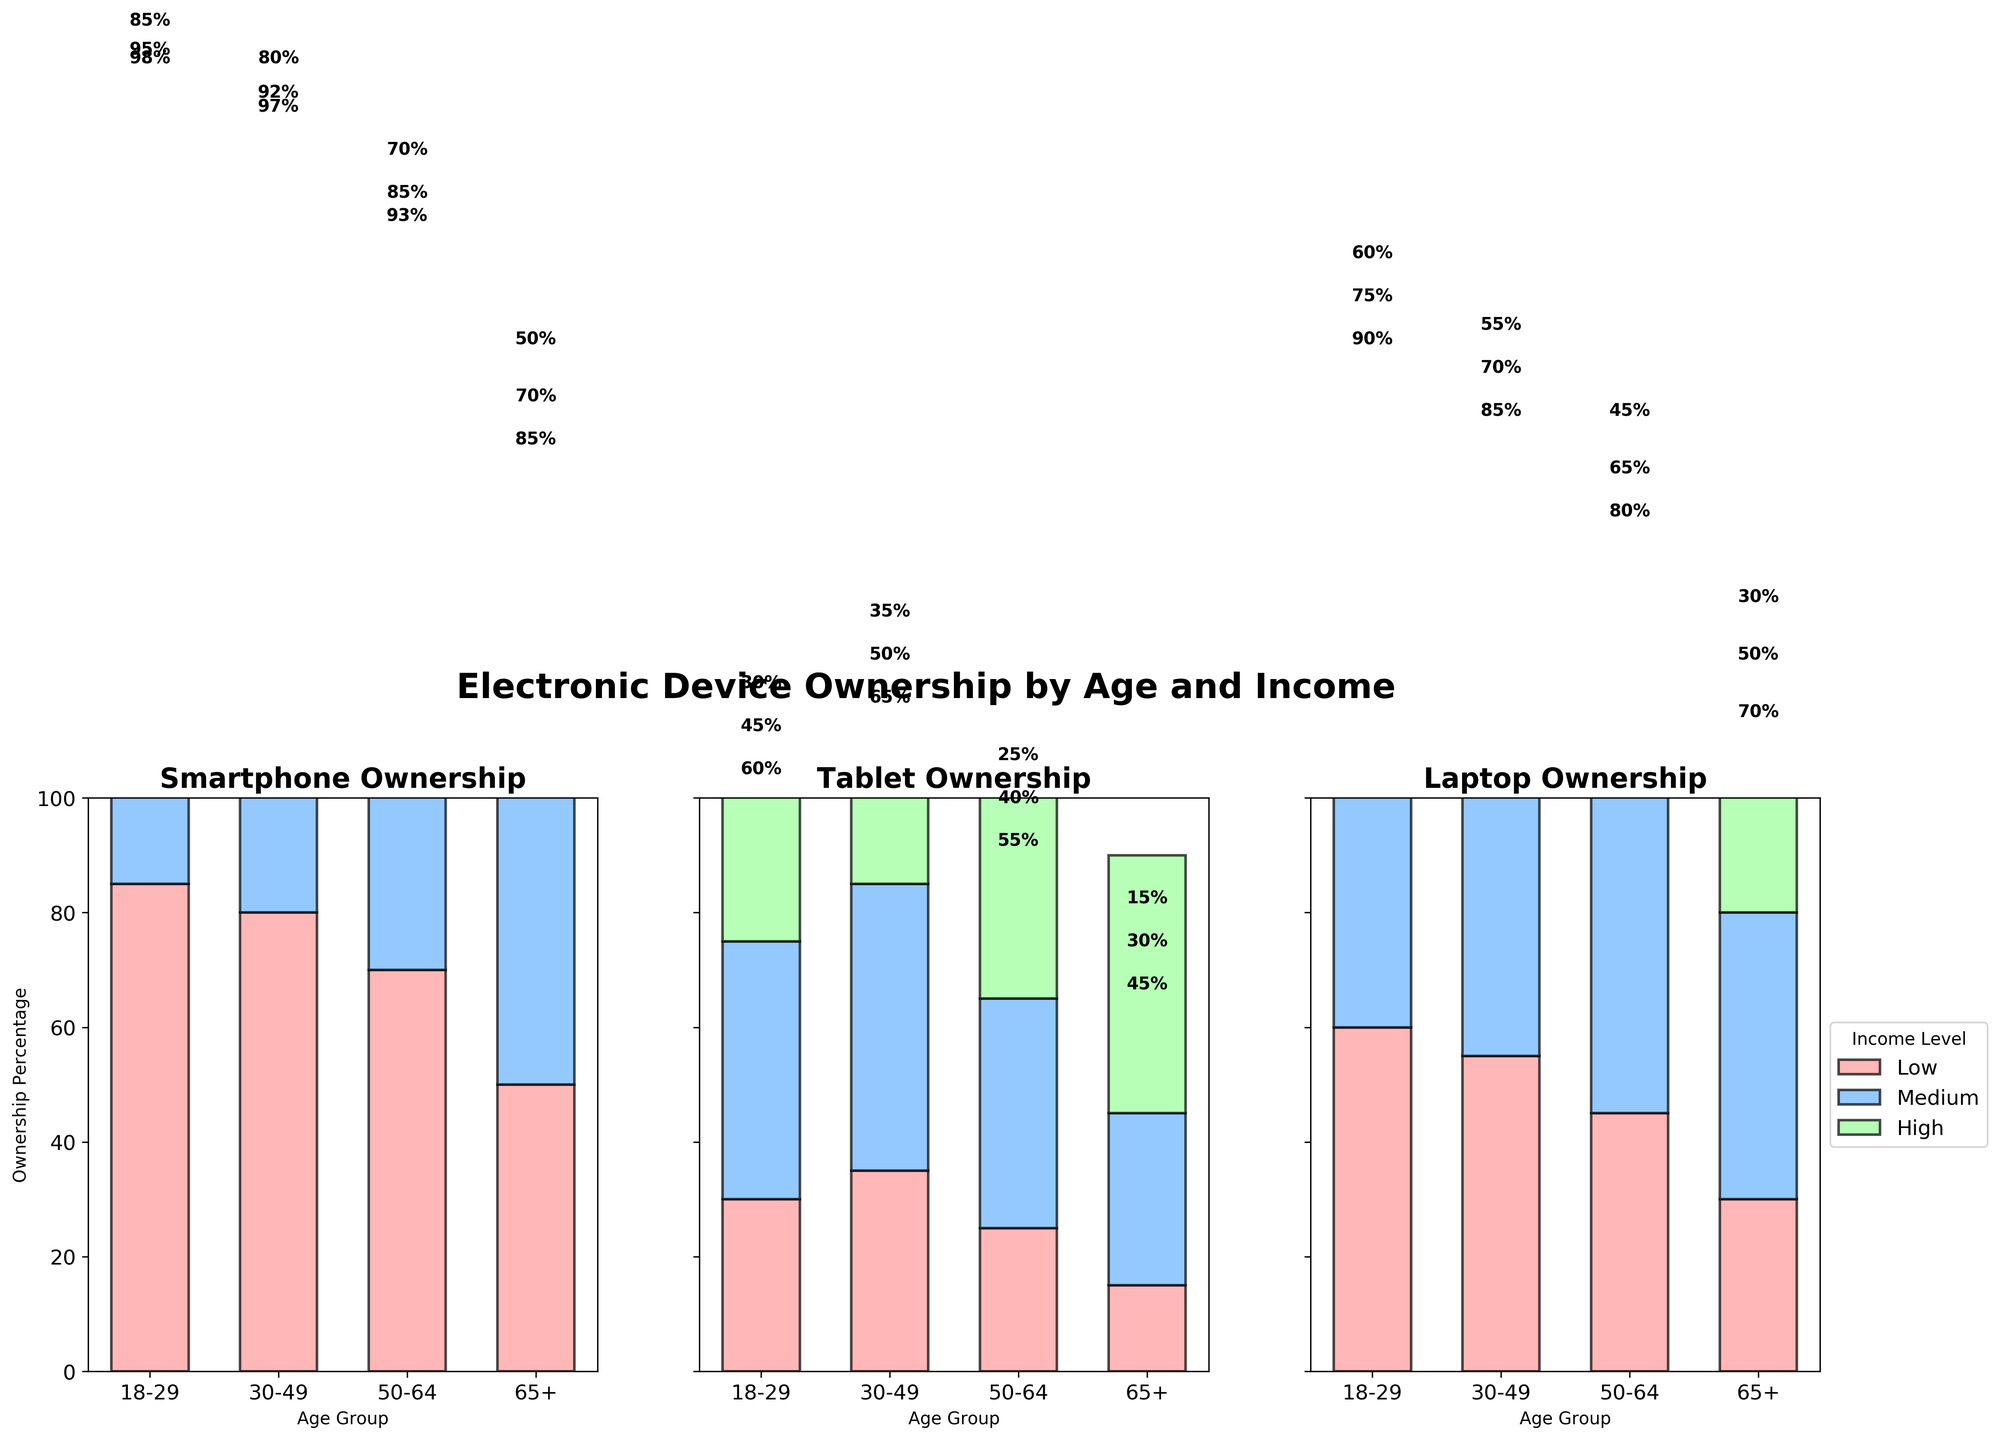What is the title of the figure? The title is usually located at the top of the figure. In this case, the figure title is centered at the top and reads "Electronic Device Ownership by Age and Income."
Answer: Electronic Device Ownership by Age and Income Which device has the highest ownership percentage among the 18-29 age group in the high-income level? Look at the section labeled "18-29" on the x-axis, then find the high-income (usually color-coded) bars for each device. Check the numbers inside or near the bars.
Answer: Smartphone What is the ownership percentage of tablets among individuals aged 65+ with a medium income? Find the section for "65+" age group, then look for the medium-income (likely a distinct color). The percentage is written inside or near the corresponding bar for the "Tablet" category.
Answer: 30% Which age group has the lowest ownership percentage for laptops in the low-income level? Check all low-income level bars (usually color-coded) for each age group in the "Laptop" section. Compare them to find the lowest one.
Answer: 65+ Compare the ownership percentages of smartphones between the 30-49 and 50-64 age groups for the medium income level. Look at the medium-income bars for both the 30-49 and 50-64 age groups in the "Smartphone" section. Compare the percentages indicated inside or near these bars.
Answer: 92% (30-49) and 85% (50-64) What is the difference in laptop ownership percentages between the lowest and highest income levels in the 65+ age group? Identify the laptop ownership percentages for both low and high-income levels in the 65+ age group. Subtract the low-income percentage from the high-income percentage.
Answer: 70% - 30% = 40% Which device shows the smallest increase in ownership percentage from medium to high-income levels for the 50-64 age group? For the 50-64 age group, examine the bars for medium and high-income levels across all devices. Calculate the difference in ownership percentages for each device. The smallest difference indicates the smallest increase.
Answer: Tablet (55% - 40% = 15%) Is the smartphone ownership percentage consistently higher than laptop ownership across all age groups and income levels? Compare the percentages of smartphone and laptop ownership for each age group and income level to see if smartphone ownership is always higher.
Answer: Yes What trend can be observed in tablet ownership as income level increases across all age groups? For each age group, observe how tablet ownership changes from low to high-income levels. Summarize the general trend.
Answer: Tablet ownership increases as income level increases 